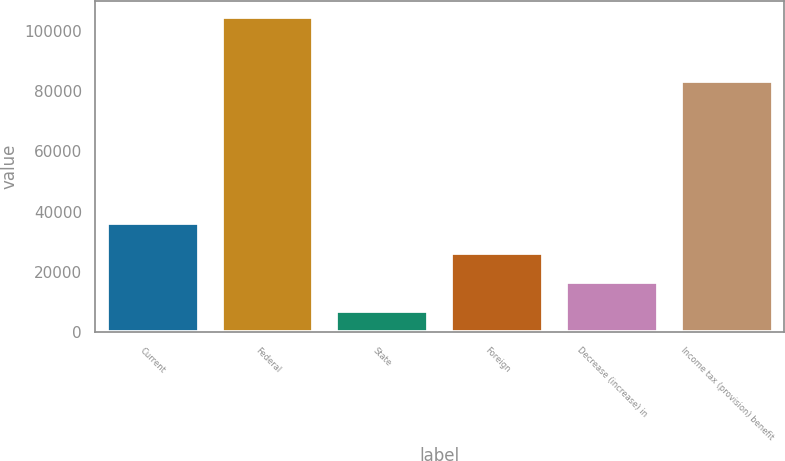Convert chart. <chart><loc_0><loc_0><loc_500><loc_500><bar_chart><fcel>Current<fcel>Federal<fcel>State<fcel>Foreign<fcel>Decrease (increase) in<fcel>Income tax (provision) benefit<nl><fcel>36243.7<fcel>104626<fcel>6937<fcel>26474.8<fcel>16705.9<fcel>83338<nl></chart> 